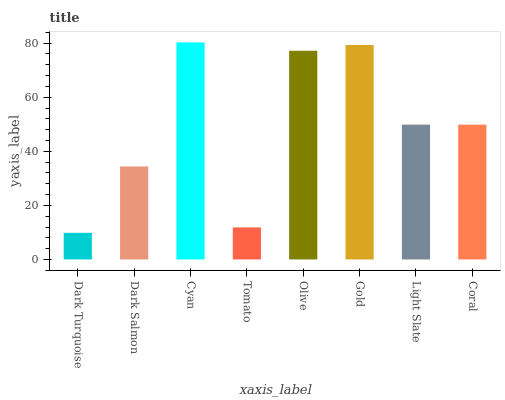Is Dark Turquoise the minimum?
Answer yes or no. Yes. Is Cyan the maximum?
Answer yes or no. Yes. Is Dark Salmon the minimum?
Answer yes or no. No. Is Dark Salmon the maximum?
Answer yes or no. No. Is Dark Salmon greater than Dark Turquoise?
Answer yes or no. Yes. Is Dark Turquoise less than Dark Salmon?
Answer yes or no. Yes. Is Dark Turquoise greater than Dark Salmon?
Answer yes or no. No. Is Dark Salmon less than Dark Turquoise?
Answer yes or no. No. Is Light Slate the high median?
Answer yes or no. Yes. Is Coral the low median?
Answer yes or no. Yes. Is Gold the high median?
Answer yes or no. No. Is Dark Turquoise the low median?
Answer yes or no. No. 